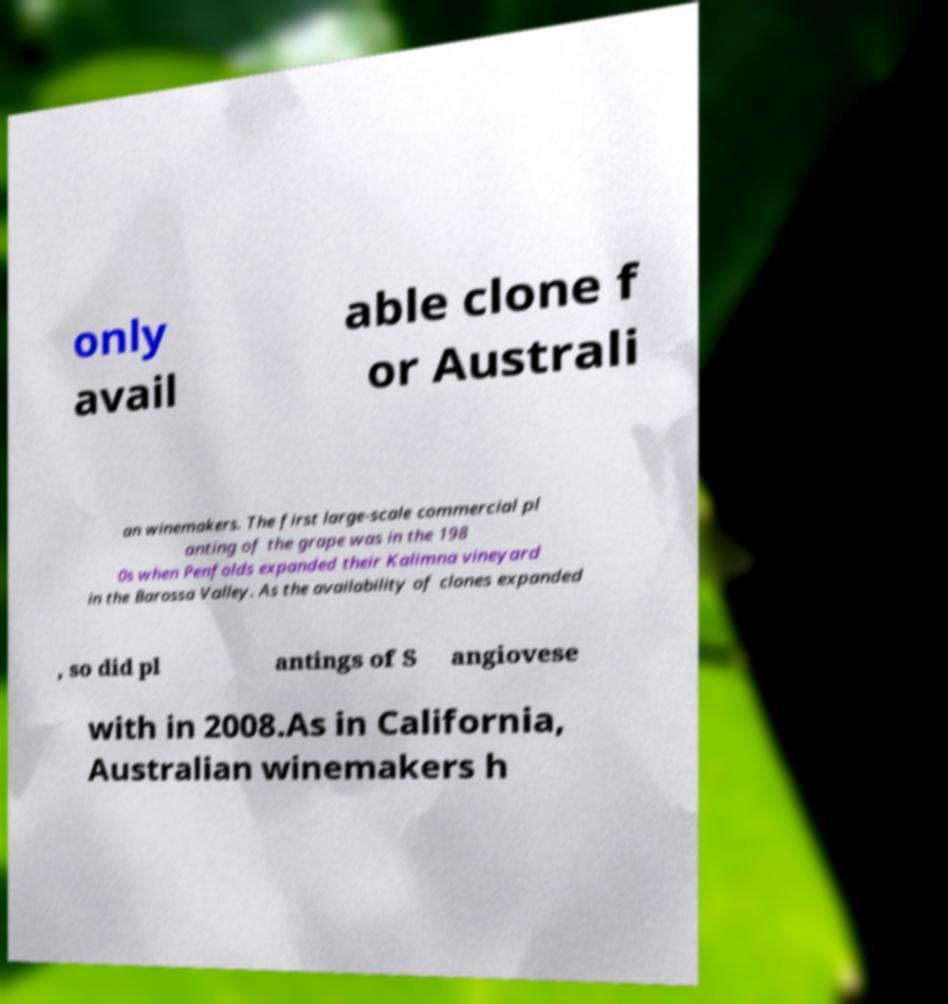Can you accurately transcribe the text from the provided image for me? only avail able clone f or Australi an winemakers. The first large-scale commercial pl anting of the grape was in the 198 0s when Penfolds expanded their Kalimna vineyard in the Barossa Valley. As the availability of clones expanded , so did pl antings of S angiovese with in 2008.As in California, Australian winemakers h 